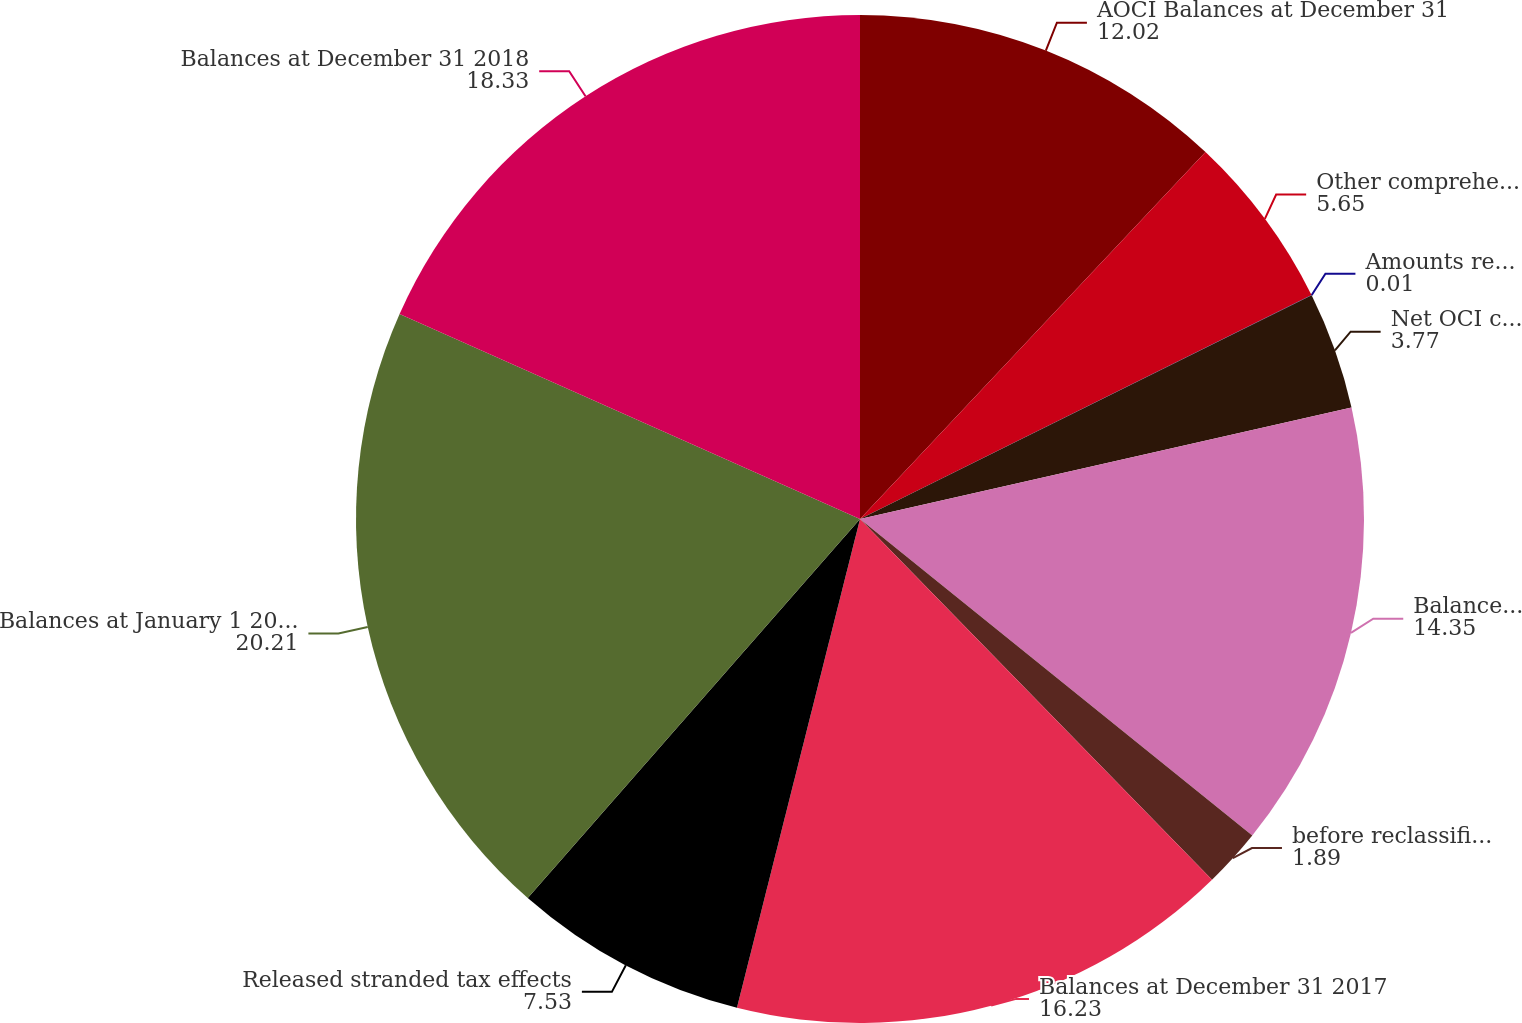Convert chart to OTSL. <chart><loc_0><loc_0><loc_500><loc_500><pie_chart><fcel>AOCI Balances at December 31<fcel>Other comprehensive income<fcel>Amounts reclassified from AOCI<fcel>Net OCI changes<fcel>Balances at December 31 2016<fcel>before reclassifications<fcel>Balances at December 31 2017<fcel>Released stranded tax effects<fcel>Balances at January 1 2018 due<fcel>Balances at December 31 2018<nl><fcel>12.02%<fcel>5.65%<fcel>0.01%<fcel>3.77%<fcel>14.35%<fcel>1.89%<fcel>16.23%<fcel>7.53%<fcel>20.21%<fcel>18.33%<nl></chart> 